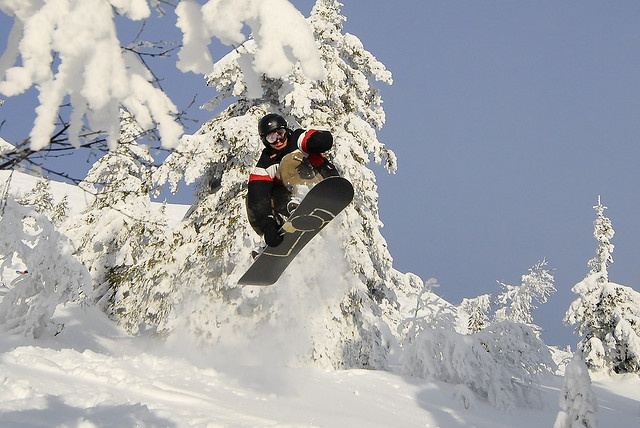Describe the objects in this image and their specific colors. I can see people in darkgray, black, gray, and lightgray tones and snowboard in darkgray, black, and gray tones in this image. 